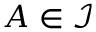<formula> <loc_0><loc_0><loc_500><loc_500>A \in { \mathcal { I } }</formula> 